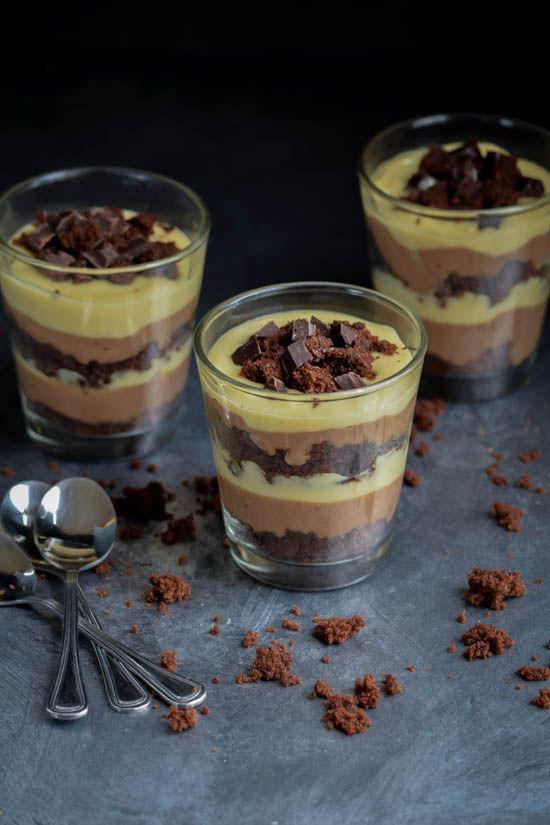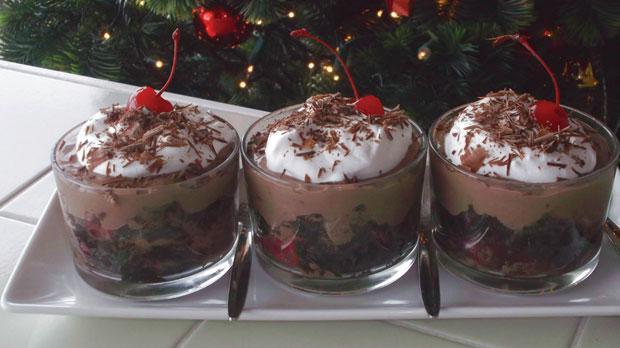The first image is the image on the left, the second image is the image on the right. Examine the images to the left and right. Is the description "There are three cups of dessert in the image on the left." accurate? Answer yes or no. Yes. The first image is the image on the left, the second image is the image on the right. Assess this claim about the two images: "An image shows a group of layered desserts topped with brown whipped cream and sprinkles.". Correct or not? Answer yes or no. No. 